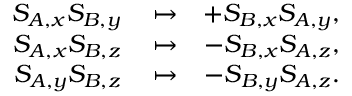Convert formula to latex. <formula><loc_0><loc_0><loc_500><loc_500>\begin{array} { r l r } { S _ { A , x } S _ { B , y } } & \mapsto } & { + S _ { B , x } S _ { A , y } , } \\ { S _ { A , x } S _ { B , z } } & \mapsto } & { - S _ { B , x } S _ { A , z } , } \\ { S _ { A , y } S _ { B , z } } & \mapsto } & { - S _ { B , y } S _ { A , z } . } \end{array}</formula> 